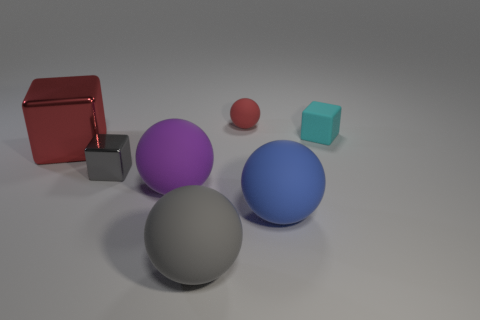Subtract 1 cubes. How many cubes are left? 2 Subtract all small blocks. How many blocks are left? 1 Subtract all gray balls. How many balls are left? 3 Add 2 metallic blocks. How many objects exist? 9 Subtract all red balls. Subtract all cyan blocks. How many balls are left? 3 Subtract 0 green cylinders. How many objects are left? 7 Subtract all blocks. How many objects are left? 4 Subtract all red blocks. Subtract all tiny cyan matte things. How many objects are left? 5 Add 2 big things. How many big things are left? 6 Add 1 tiny cyan rubber blocks. How many tiny cyan rubber blocks exist? 2 